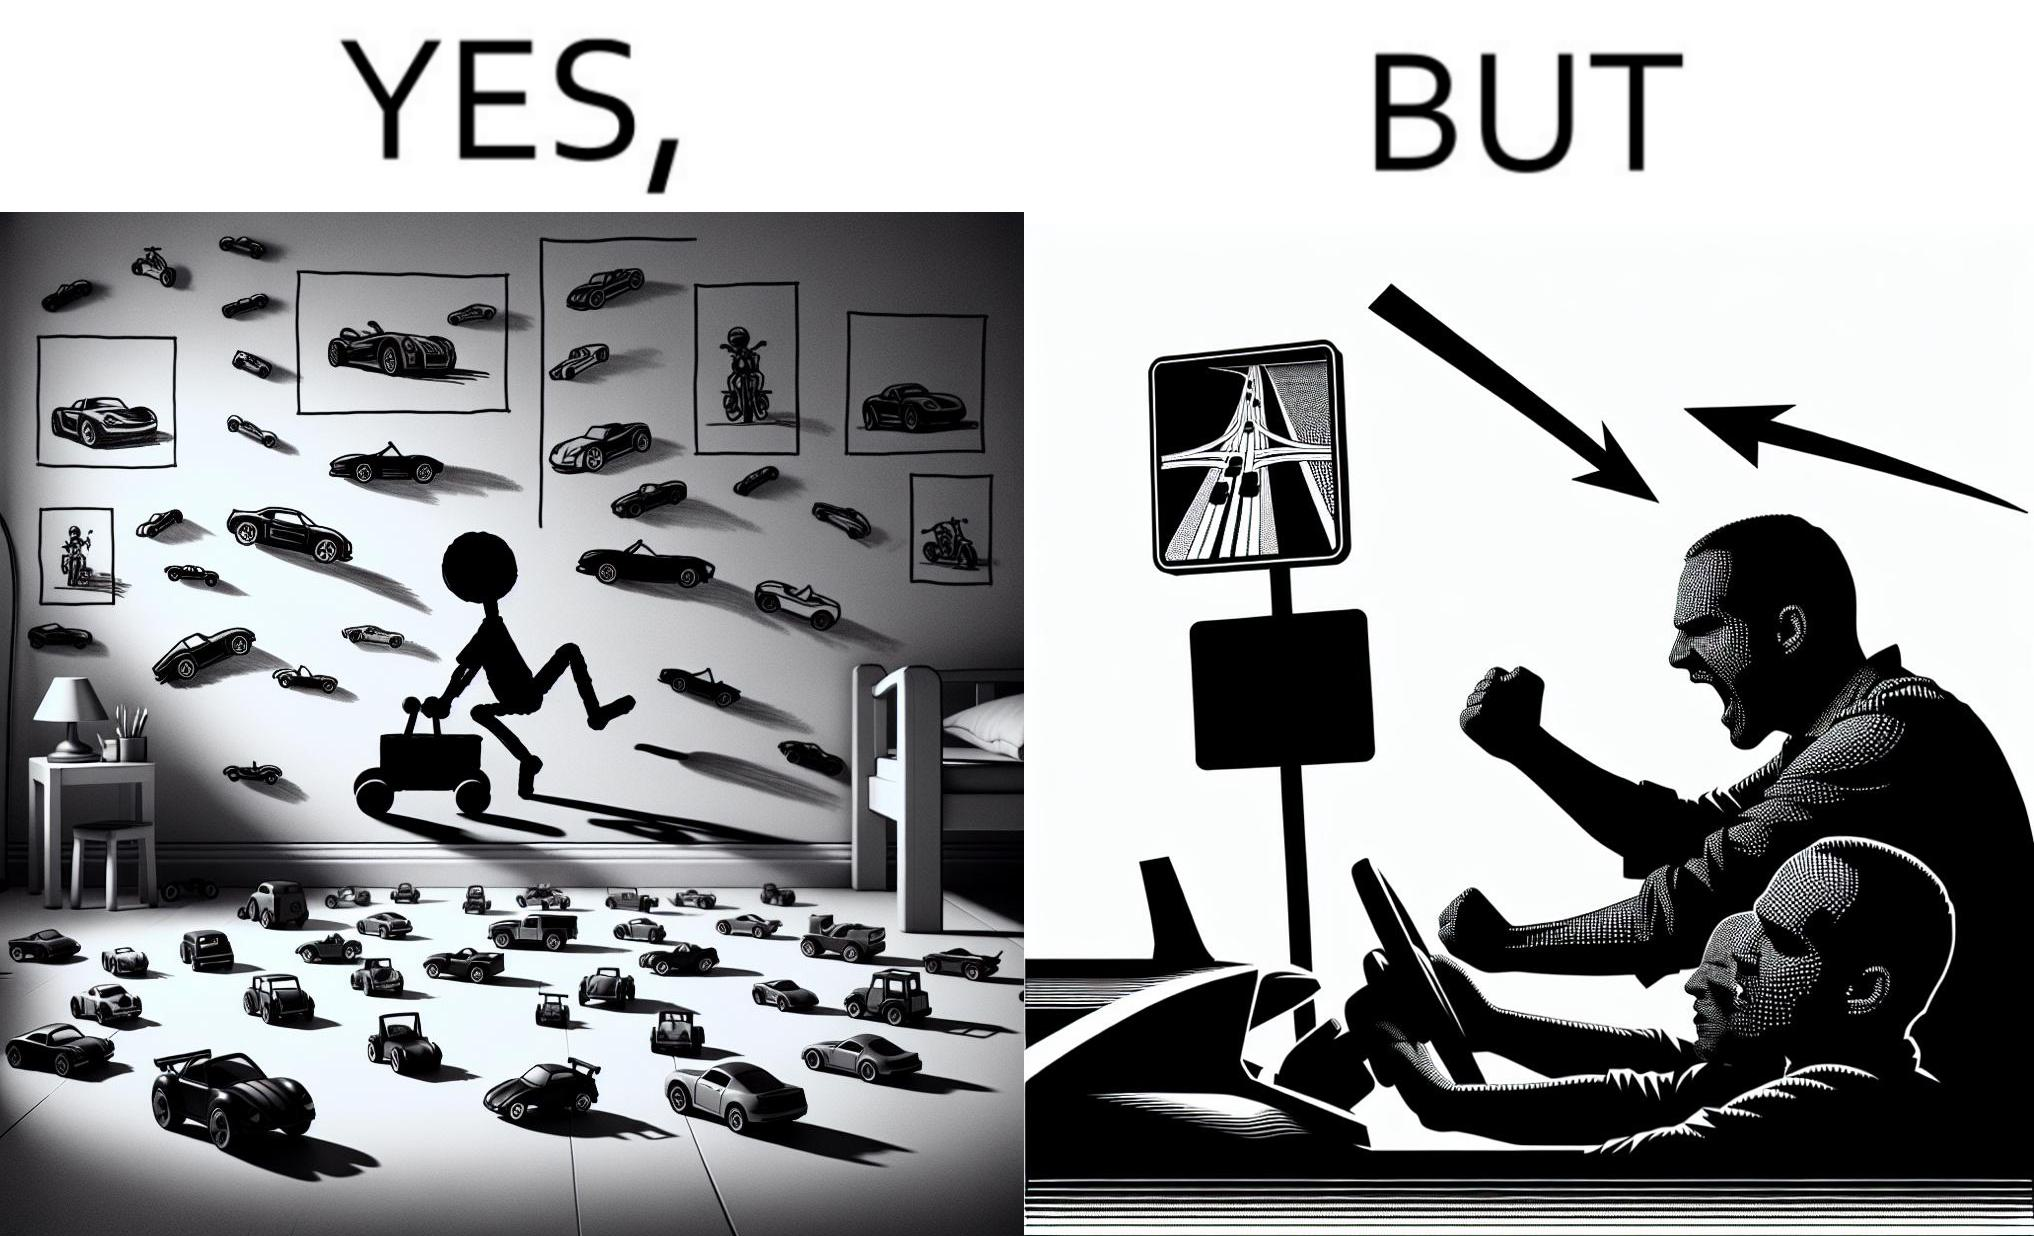Describe what you see in this image. The image is funny beaucse while the person as a child enjoyed being around cars, had various small toy cars and even rode a bigger toy car, as as grown up he does not enjoy being in a car during a traffic jam while he is driving . 